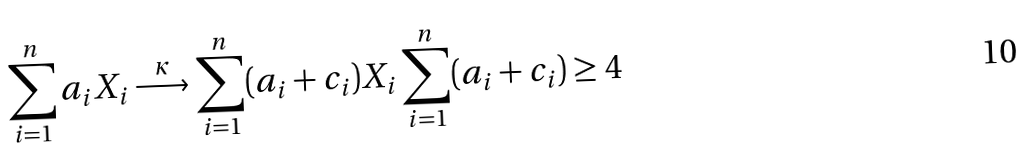<formula> <loc_0><loc_0><loc_500><loc_500>\sum _ { i = 1 } ^ { n } a _ { i } X _ { i } \stackrel { \kappa } { \longrightarrow } \sum _ { i = 1 } ^ { n } ( a _ { i } + c _ { i } ) X _ { i } \sum _ { i = 1 } ^ { n } ( a _ { i } + c _ { i } ) \geq 4</formula> 